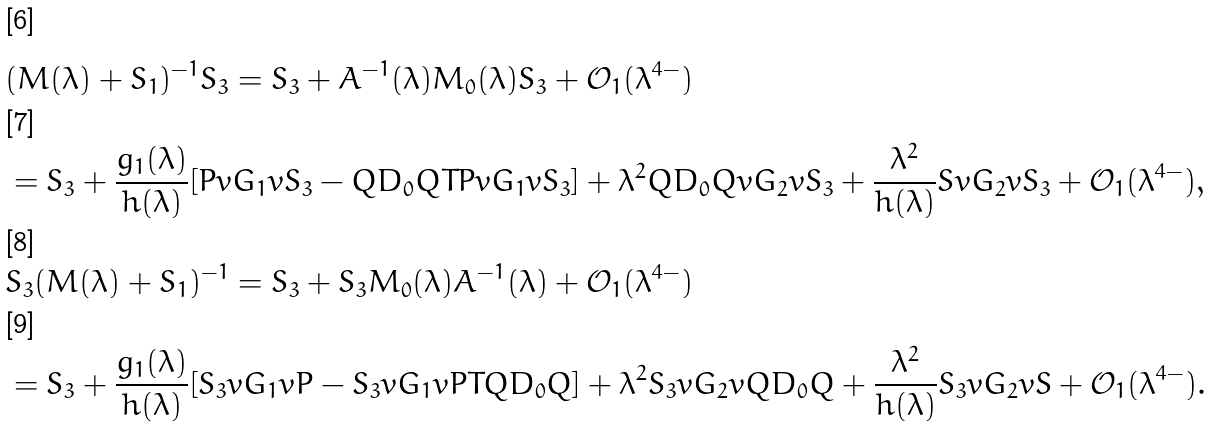<formula> <loc_0><loc_0><loc_500><loc_500>& ( M ( \lambda ) + S _ { 1 } ) ^ { - 1 } S _ { 3 } = S _ { 3 } + A ^ { - 1 } ( \lambda ) M _ { 0 } ( \lambda ) S _ { 3 } + \mathcal { O } _ { 1 } ( \lambda ^ { 4 - } ) \\ & = S _ { 3 } + \frac { g _ { 1 } ( \lambda ) } { h ( \lambda ) } [ P v G _ { 1 } v S _ { 3 } - Q D _ { 0 } Q T P v G _ { 1 } v S _ { 3 } ] + \lambda ^ { 2 } Q D _ { 0 } Q v G _ { 2 } v S _ { 3 } + \frac { \lambda ^ { 2 } } { h ( \lambda ) } S v G _ { 2 } v S _ { 3 } + \mathcal { O } _ { 1 } ( \lambda ^ { 4 - } ) , \\ & S _ { 3 } ( M ( \lambda ) + S _ { 1 } ) ^ { - 1 } = S _ { 3 } + S _ { 3 } M _ { 0 } ( \lambda ) A ^ { - 1 } ( \lambda ) + \mathcal { O } _ { 1 } ( \lambda ^ { 4 - } ) \\ & = S _ { 3 } + \frac { g _ { 1 } ( \lambda ) } { h ( \lambda ) } [ S _ { 3 } v G _ { 1 } v P - S _ { 3 } v G _ { 1 } v P T Q D _ { 0 } Q ] + \lambda ^ { 2 } S _ { 3 } v G _ { 2 } v Q D _ { 0 } Q + \frac { \lambda ^ { 2 } } { h ( \lambda ) } S _ { 3 } v G _ { 2 } v S + \mathcal { O } _ { 1 } ( \lambda ^ { 4 - } ) .</formula> 